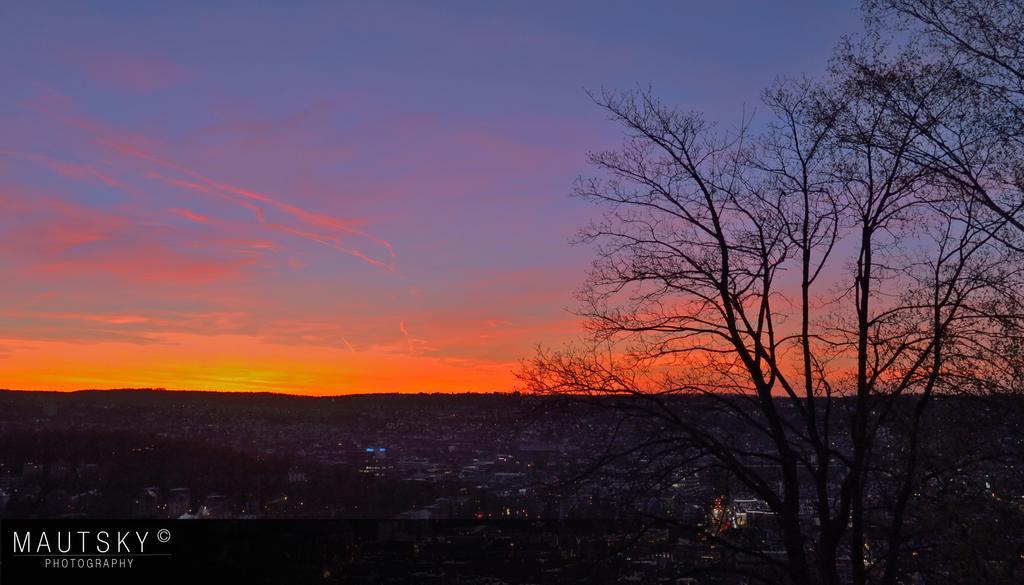Could you give a brief overview of what you see in this image? This picture is clicked outside the city. In the right bottom of the picture, we see trees and there are many buildings in the background. At the top of the picture we see the sky. 